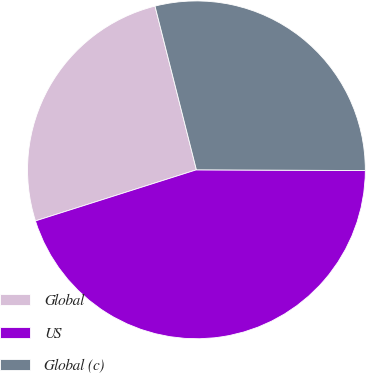Convert chart. <chart><loc_0><loc_0><loc_500><loc_500><pie_chart><fcel>Global<fcel>US<fcel>Global (c)<nl><fcel>25.95%<fcel>45.04%<fcel>29.01%<nl></chart> 